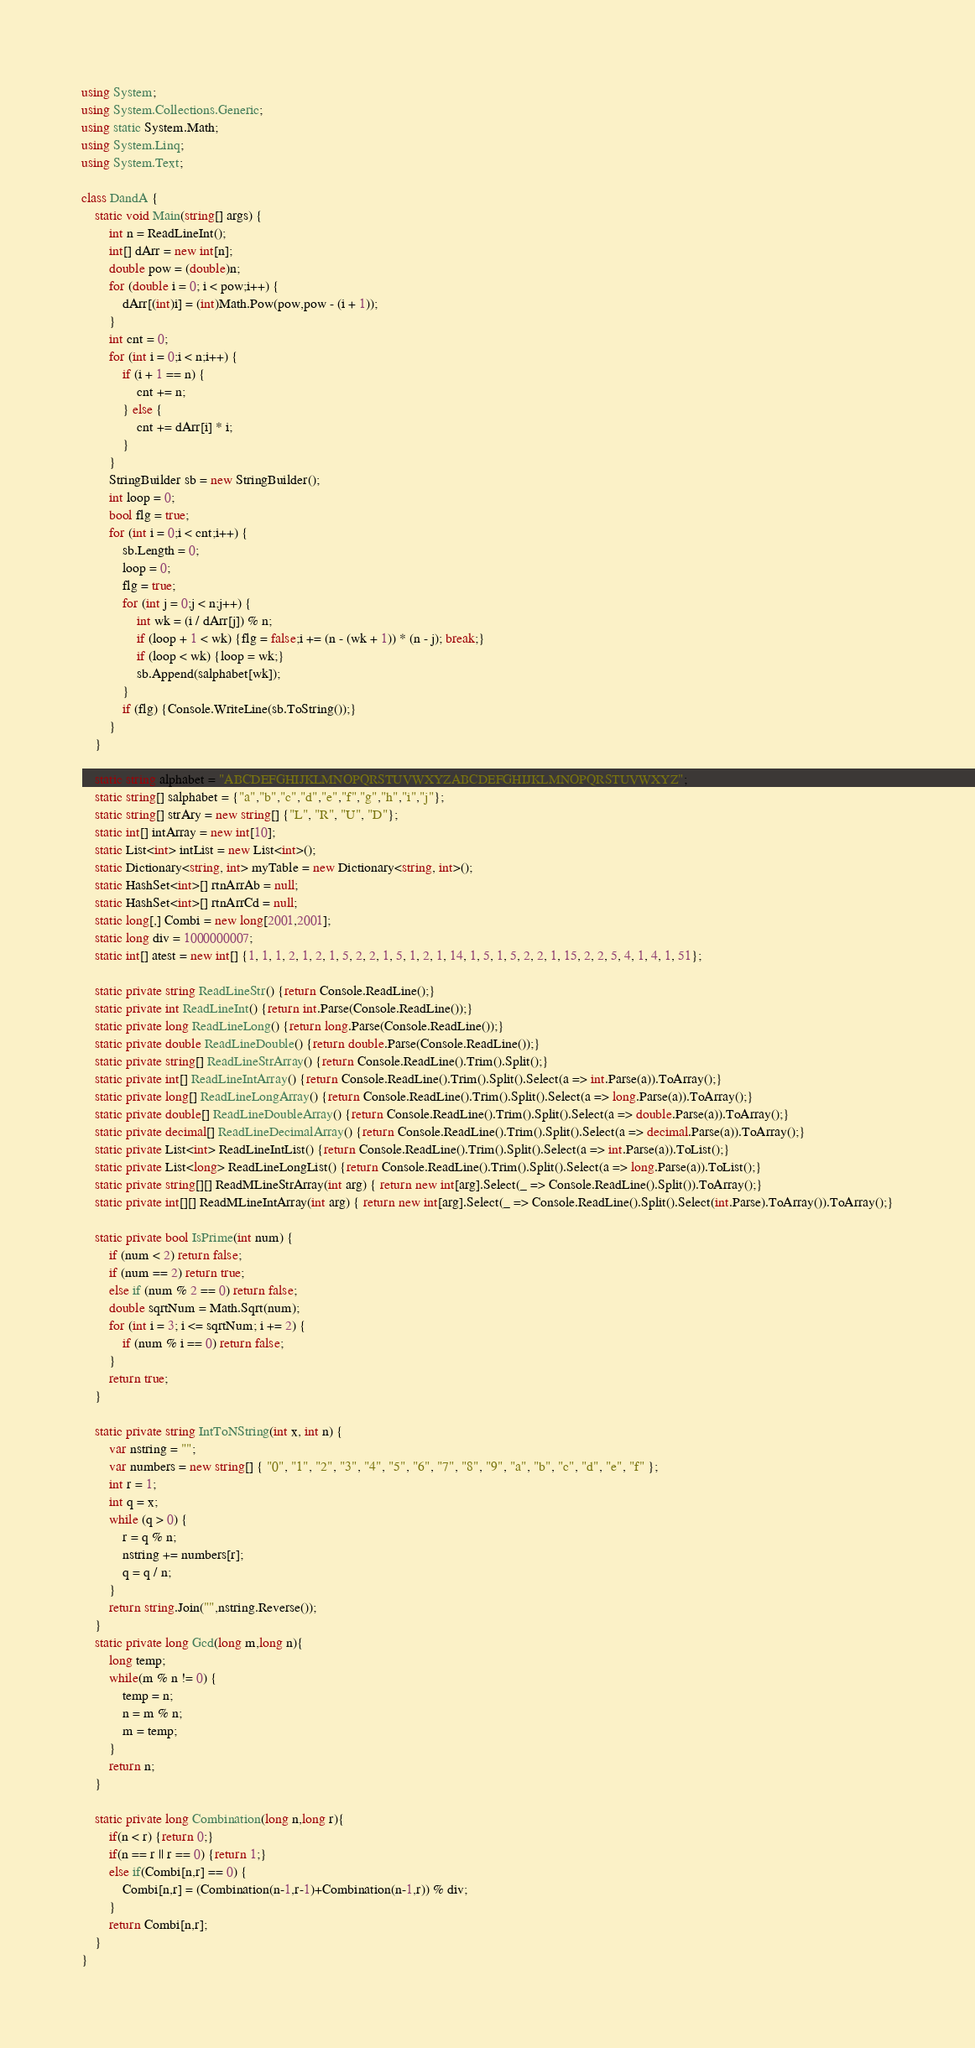<code> <loc_0><loc_0><loc_500><loc_500><_C#_>using System;
using System.Collections.Generic;
using static System.Math;
using System.Linq;
using System.Text;
 
class DandA {
    static void Main(string[] args) {
        int n = ReadLineInt();
        int[] dArr = new int[n];
        double pow = (double)n;
        for (double i = 0; i < pow;i++) {
            dArr[(int)i] = (int)Math.Pow(pow,pow - (i + 1));
        }
        int cnt = 0;
        for (int i = 0;i < n;i++) {
            if (i + 1 == n) {
                cnt += n;
            } else {
                cnt += dArr[i] * i;
            }
        }
        StringBuilder sb = new StringBuilder();
        int loop = 0;
        bool flg = true;
        for (int i = 0;i < cnt;i++) {
            sb.Length = 0;
            loop = 0;
            flg = true;
            for (int j = 0;j < n;j++) {
                int wk = (i / dArr[j]) % n;
                if (loop + 1 < wk) {flg = false;i += (n - (wk + 1)) * (n - j); break;}
                if (loop < wk) {loop = wk;}
                sb.Append(salphabet[wk]);
            }
            if (flg) {Console.WriteLine(sb.ToString());}
        }
    }
 
    static string alphabet = "ABCDEFGHIJKLMNOPQRSTUVWXYZABCDEFGHIJKLMNOPQRSTUVWXYZ";
    static string[] salphabet = {"a","b","c","d","e","f","g","h","i","j"};
    static string[] strAry = new string[] {"L", "R", "U", "D"};
    static int[] intArray = new int[10];
    static List<int> intList = new List<int>();
    static Dictionary<string, int> myTable = new Dictionary<string, int>();
    static HashSet<int>[] rtnArrAb = null;
    static HashSet<int>[] rtnArrCd = null;
    static long[,] Combi = new long[2001,2001];
    static long div = 1000000007;
    static int[] atest = new int[] {1, 1, 1, 2, 1, 2, 1, 5, 2, 2, 1, 5, 1, 2, 1, 14, 1, 5, 1, 5, 2, 2, 1, 15, 2, 2, 5, 4, 1, 4, 1, 51};
  
    static private string ReadLineStr() {return Console.ReadLine();}
    static private int ReadLineInt() {return int.Parse(Console.ReadLine());}
    static private long ReadLineLong() {return long.Parse(Console.ReadLine());}
    static private double ReadLineDouble() {return double.Parse(Console.ReadLine());}
    static private string[] ReadLineStrArray() {return Console.ReadLine().Trim().Split();}
    static private int[] ReadLineIntArray() {return Console.ReadLine().Trim().Split().Select(a => int.Parse(a)).ToArray();}
    static private long[] ReadLineLongArray() {return Console.ReadLine().Trim().Split().Select(a => long.Parse(a)).ToArray();}
    static private double[] ReadLineDoubleArray() {return Console.ReadLine().Trim().Split().Select(a => double.Parse(a)).ToArray();}
    static private decimal[] ReadLineDecimalArray() {return Console.ReadLine().Trim().Split().Select(a => decimal.Parse(a)).ToArray();}
    static private List<int> ReadLineIntList() {return Console.ReadLine().Trim().Split().Select(a => int.Parse(a)).ToList();}
    static private List<long> ReadLineLongList() {return Console.ReadLine().Trim().Split().Select(a => long.Parse(a)).ToList();}
    static private string[][] ReadMLineStrArray(int arg) { return new int[arg].Select(_ => Console.ReadLine().Split()).ToArray();}
    static private int[][] ReadMLineIntArray(int arg) { return new int[arg].Select(_ => Console.ReadLine().Split().Select(int.Parse).ToArray()).ToArray();}
 
    static private bool IsPrime(int num) {
        if (num < 2) return false;
        if (num == 2) return true;
        else if (num % 2 == 0) return false;
        double sqrtNum = Math.Sqrt(num);
        for (int i = 3; i <= sqrtNum; i += 2) {
            if (num % i == 0) return false;
        }
        return true;
    }
  
    static private string IntToNString(int x, int n) {
        var nstring = "";
        var numbers = new string[] { "0", "1", "2", "3", "4", "5", "6", "7", "8", "9", "a", "b", "c", "d", "e", "f" };
        int r = 1;
        int q = x;
        while (q > 0) {
            r = q % n;
            nstring += numbers[r];
            q = q / n;
        }
        return string.Join("",nstring.Reverse());
    }
    static private long Gcd(long m,long n){
        long temp;
        while(m % n != 0) {
            temp = n;
            n = m % n;
            m = temp;
        }
        return n;
    }
 
    static private long Combination(long n,long r){
        if(n < r) {return 0;}
        if(n == r || r == 0) {return 1;}
        else if(Combi[n,r] == 0) {
            Combi[n,r] = (Combination(n-1,r-1)+Combination(n-1,r)) % div;
        }
        return Combi[n,r];
    }
}</code> 